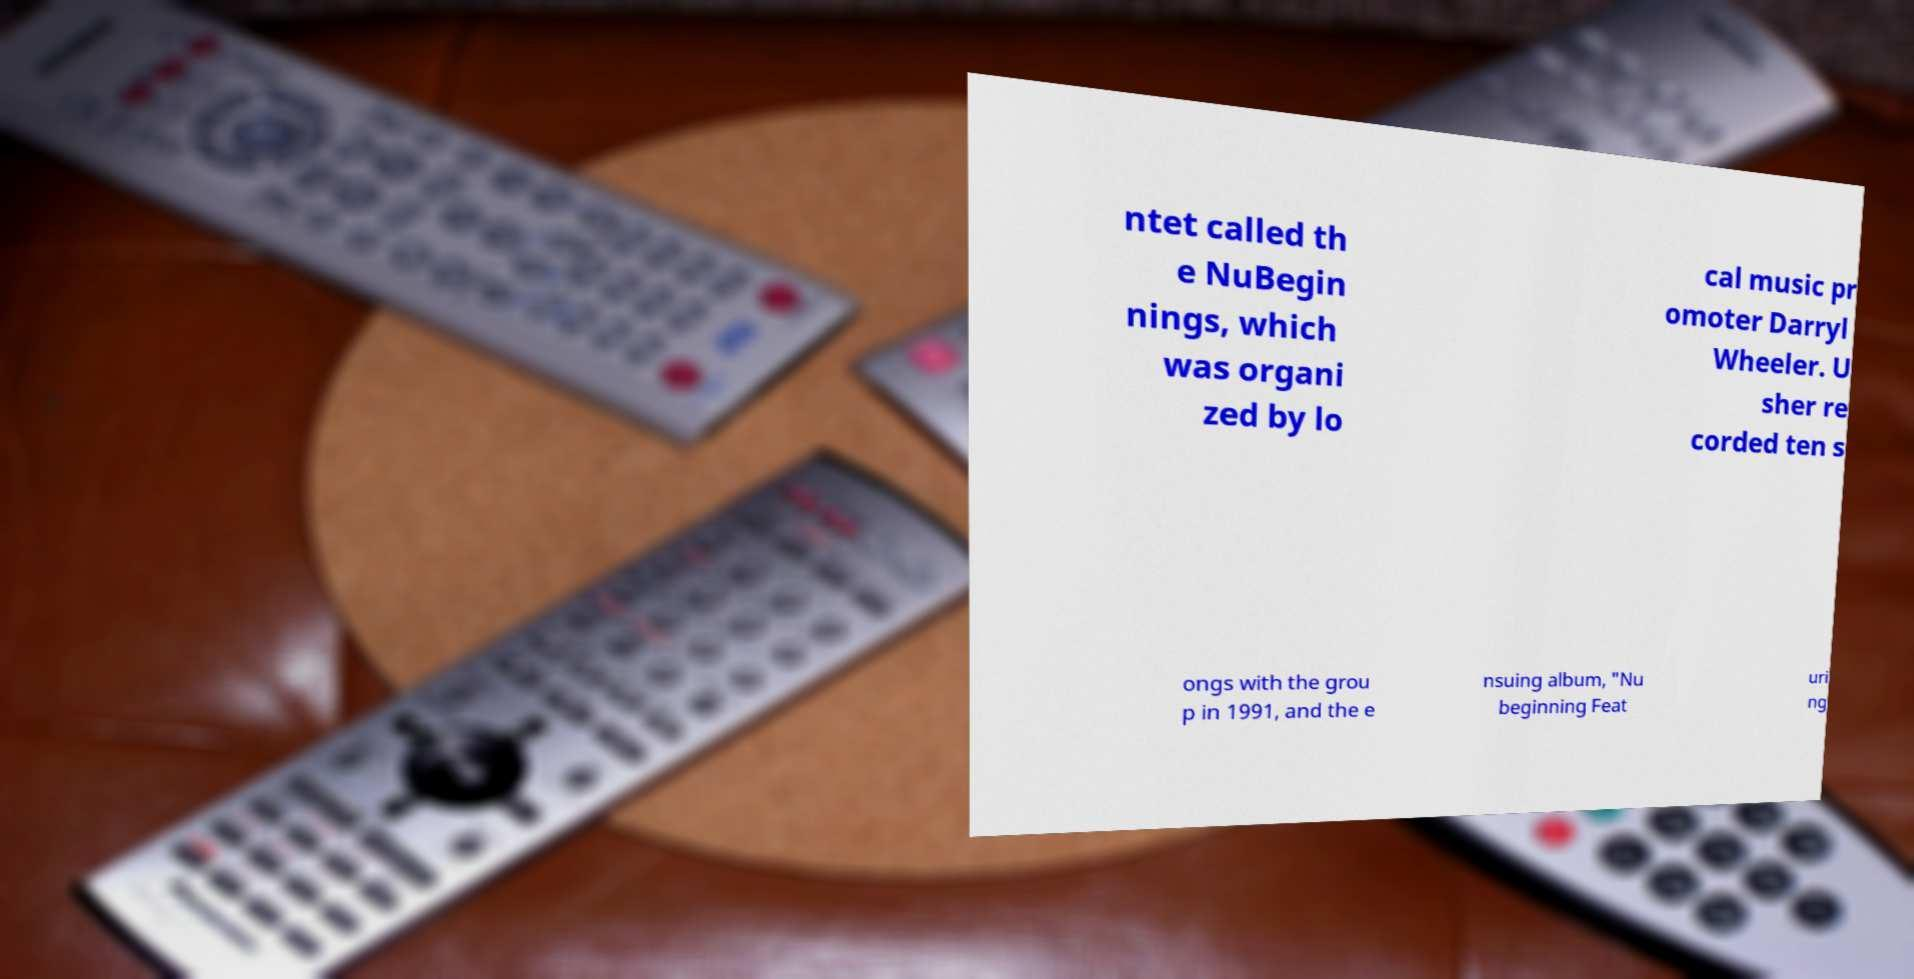Please identify and transcribe the text found in this image. ntet called th e NuBegin nings, which was organi zed by lo cal music pr omoter Darryl Wheeler. U sher re corded ten s ongs with the grou p in 1991, and the e nsuing album, "Nu beginning Feat uri ng 